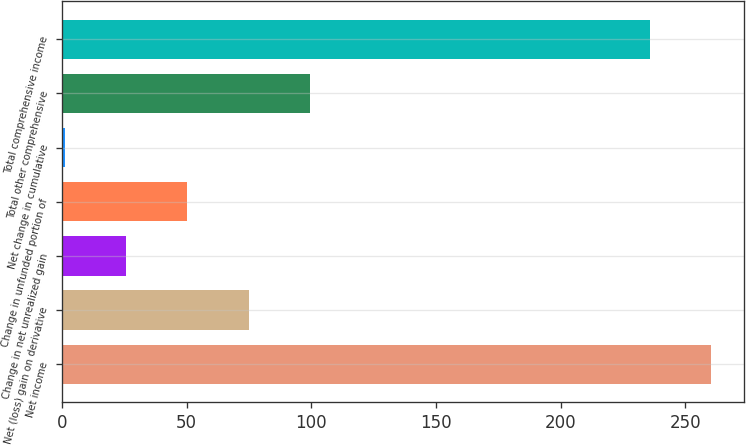Convert chart. <chart><loc_0><loc_0><loc_500><loc_500><bar_chart><fcel>Net income<fcel>Net (loss) gain on derivative<fcel>Change in net unrealized gain<fcel>Change in unfunded portion of<fcel>Net change in cumulative<fcel>Total other comprehensive<fcel>Total comprehensive income<nl><fcel>260.43<fcel>74.99<fcel>25.73<fcel>50.36<fcel>1.1<fcel>99.62<fcel>235.8<nl></chart> 